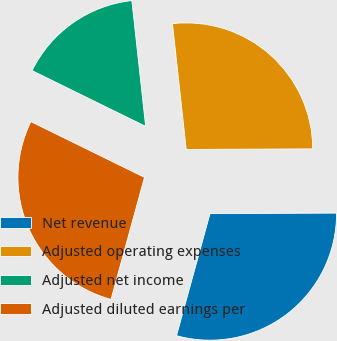Convert chart to OTSL. <chart><loc_0><loc_0><loc_500><loc_500><pie_chart><fcel>Net revenue<fcel>Adjusted operating expenses<fcel>Adjusted net income<fcel>Adjusted diluted earnings per<nl><fcel>29.33%<fcel>26.67%<fcel>16.0%<fcel>28.0%<nl></chart> 